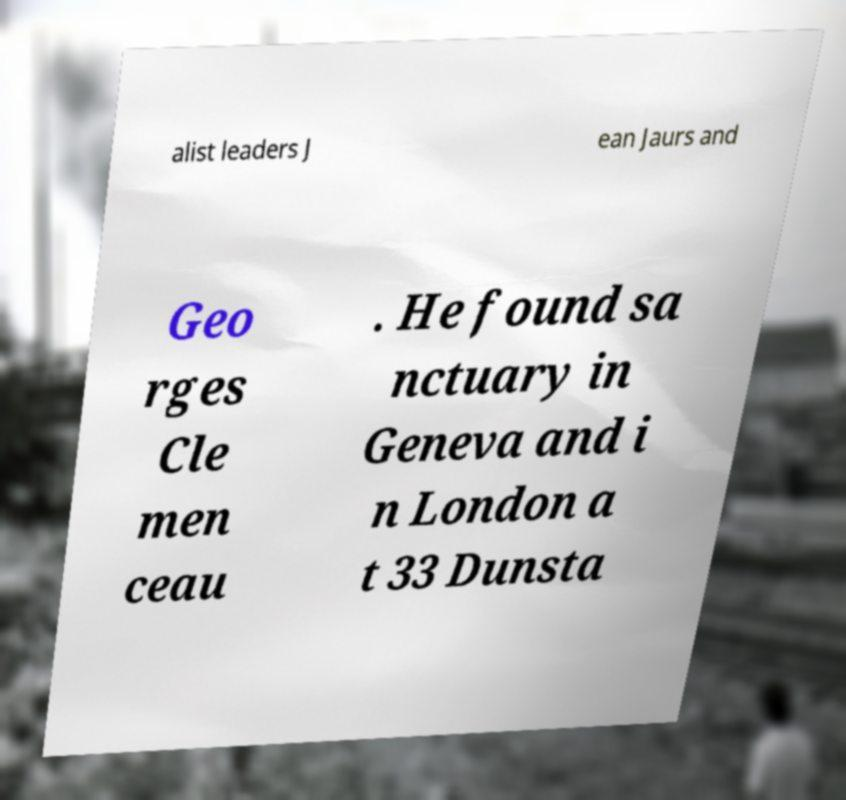There's text embedded in this image that I need extracted. Can you transcribe it verbatim? alist leaders J ean Jaurs and Geo rges Cle men ceau . He found sa nctuary in Geneva and i n London a t 33 Dunsta 